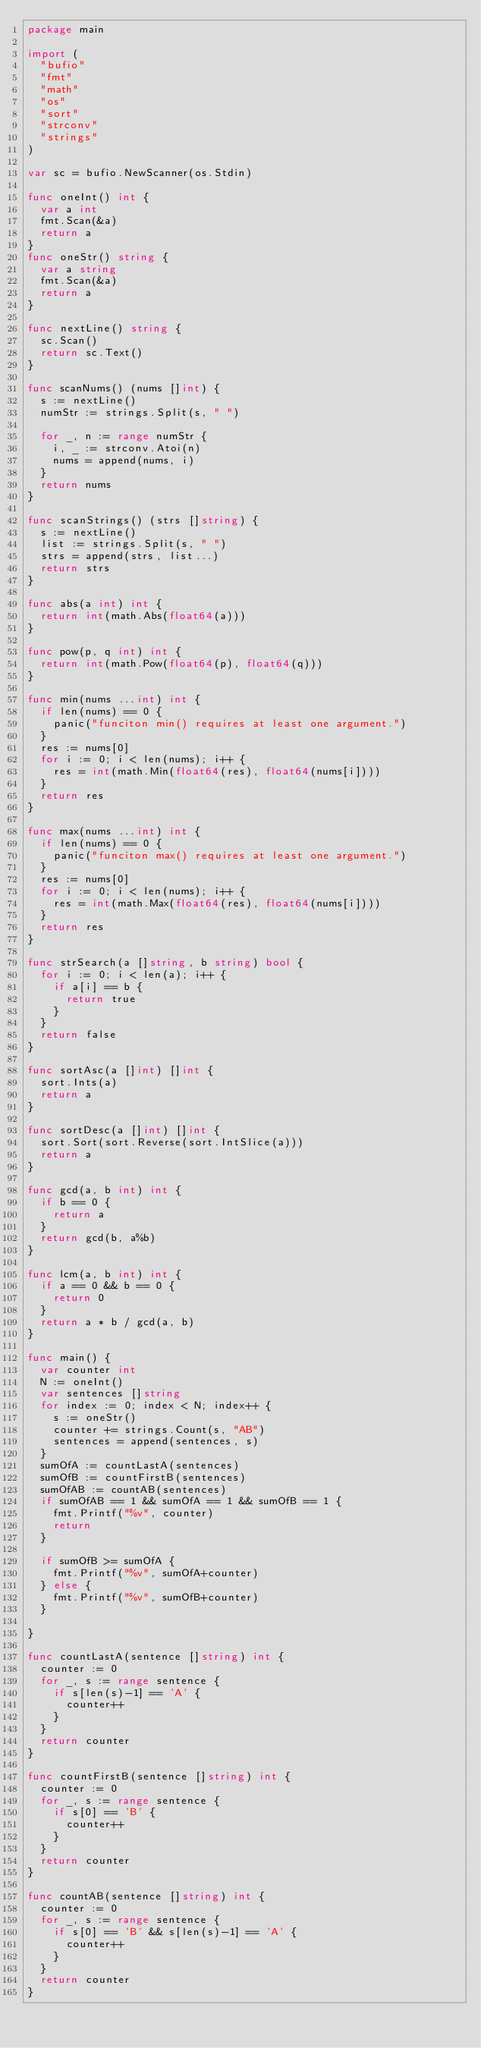Convert code to text. <code><loc_0><loc_0><loc_500><loc_500><_Go_>package main

import (
	"bufio"
	"fmt"
	"math"
	"os"
	"sort"
	"strconv"
	"strings"
)

var sc = bufio.NewScanner(os.Stdin)

func oneInt() int {
	var a int
	fmt.Scan(&a)
	return a
}
func oneStr() string {
	var a string
	fmt.Scan(&a)
	return a
}

func nextLine() string {
	sc.Scan()
	return sc.Text()
}

func scanNums() (nums []int) {
	s := nextLine()
	numStr := strings.Split(s, " ")

	for _, n := range numStr {
		i, _ := strconv.Atoi(n)
		nums = append(nums, i)
	}
	return nums
}

func scanStrings() (strs []string) {
	s := nextLine()
	list := strings.Split(s, " ")
	strs = append(strs, list...)
	return strs
}

func abs(a int) int {
	return int(math.Abs(float64(a)))
}

func pow(p, q int) int {
	return int(math.Pow(float64(p), float64(q)))
}

func min(nums ...int) int {
	if len(nums) == 0 {
		panic("funciton min() requires at least one argument.")
	}
	res := nums[0]
	for i := 0; i < len(nums); i++ {
		res = int(math.Min(float64(res), float64(nums[i])))
	}
	return res
}

func max(nums ...int) int {
	if len(nums) == 0 {
		panic("funciton max() requires at least one argument.")
	}
	res := nums[0]
	for i := 0; i < len(nums); i++ {
		res = int(math.Max(float64(res), float64(nums[i])))
	}
	return res
}

func strSearch(a []string, b string) bool {
	for i := 0; i < len(a); i++ {
		if a[i] == b {
			return true
		}
	}
	return false
}

func sortAsc(a []int) []int {
	sort.Ints(a)
	return a
}

func sortDesc(a []int) []int {
	sort.Sort(sort.Reverse(sort.IntSlice(a)))
	return a
}

func gcd(a, b int) int {
	if b == 0 {
		return a
	}
	return gcd(b, a%b)
}

func lcm(a, b int) int {
	if a == 0 && b == 0 {
		return 0
	}
	return a * b / gcd(a, b)
}

func main() {
	var counter int
	N := oneInt()
	var sentences []string
	for index := 0; index < N; index++ {
		s := oneStr()
		counter += strings.Count(s, "AB")
		sentences = append(sentences, s)
	}
	sumOfA := countLastA(sentences)
	sumOfB := countFirstB(sentences)
	sumOfAB := countAB(sentences)
	if sumOfAB == 1 && sumOfA == 1 && sumOfB == 1 {
		fmt.Printf("%v", counter)
		return
	}

	if sumOfB >= sumOfA {
		fmt.Printf("%v", sumOfA+counter)
	} else {
		fmt.Printf("%v", sumOfB+counter)
	}

}

func countLastA(sentence []string) int {
	counter := 0
	for _, s := range sentence {
		if s[len(s)-1] == 'A' {
			counter++
		}
	}
	return counter
}

func countFirstB(sentence []string) int {
	counter := 0
	for _, s := range sentence {
		if s[0] == 'B' {
			counter++
		}
	}
	return counter
}

func countAB(sentence []string) int {
	counter := 0
	for _, s := range sentence {
		if s[0] == 'B' && s[len(s)-1] == 'A' {
			counter++
		}
	}
	return counter
}
</code> 